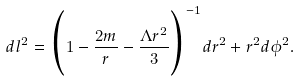Convert formula to latex. <formula><loc_0><loc_0><loc_500><loc_500>d l ^ { 2 } = \Big { ( } 1 - \frac { 2 m } { r } - \frac { \Lambda r ^ { 2 } } { 3 } \Big { ) } ^ { - 1 } d r ^ { 2 } + r ^ { 2 } d \phi ^ { 2 } .</formula> 